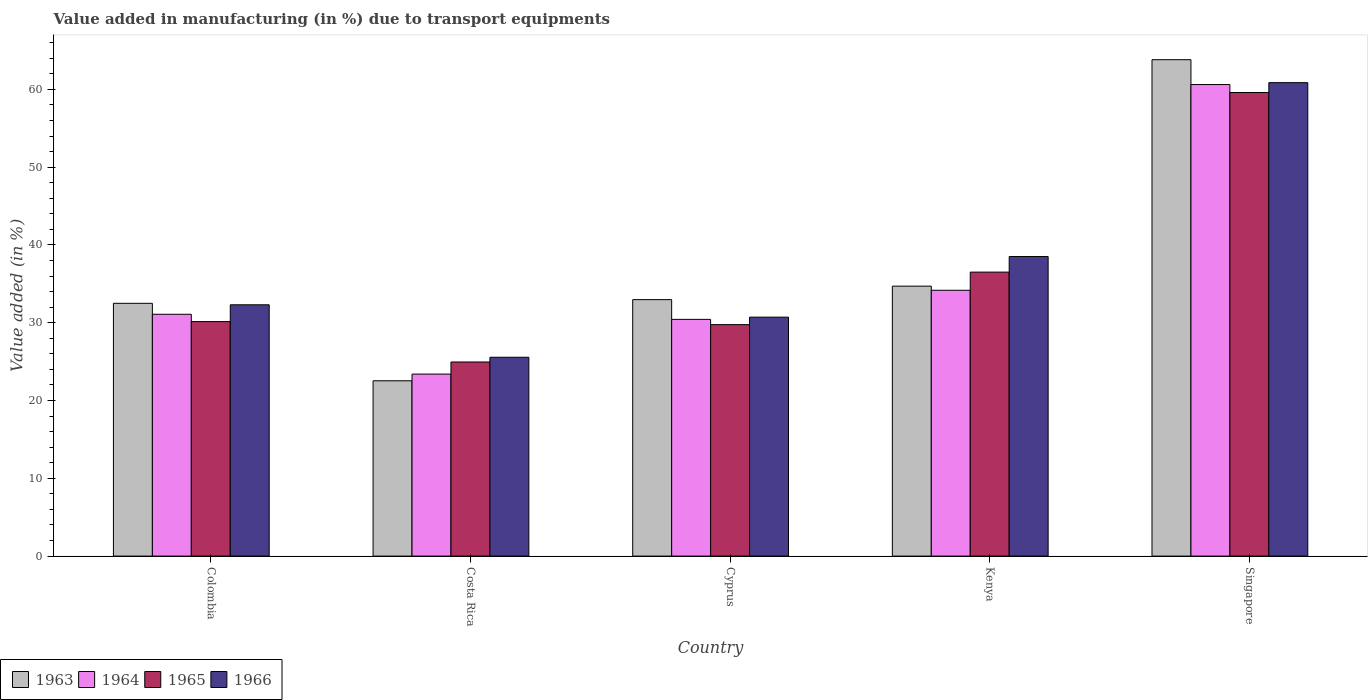How many different coloured bars are there?
Keep it short and to the point. 4. How many groups of bars are there?
Offer a terse response. 5. Are the number of bars on each tick of the X-axis equal?
Offer a very short reply. Yes. How many bars are there on the 2nd tick from the right?
Make the answer very short. 4. What is the label of the 1st group of bars from the left?
Your response must be concise. Colombia. What is the percentage of value added in manufacturing due to transport equipments in 1965 in Cyprus?
Keep it short and to the point. 29.75. Across all countries, what is the maximum percentage of value added in manufacturing due to transport equipments in 1965?
Offer a terse response. 59.59. Across all countries, what is the minimum percentage of value added in manufacturing due to transport equipments in 1963?
Your answer should be compact. 22.53. In which country was the percentage of value added in manufacturing due to transport equipments in 1964 maximum?
Provide a succinct answer. Singapore. What is the total percentage of value added in manufacturing due to transport equipments in 1963 in the graph?
Ensure brevity in your answer.  186.5. What is the difference between the percentage of value added in manufacturing due to transport equipments in 1966 in Costa Rica and that in Singapore?
Your answer should be compact. -35.3. What is the difference between the percentage of value added in manufacturing due to transport equipments in 1964 in Costa Rica and the percentage of value added in manufacturing due to transport equipments in 1963 in Kenya?
Keep it short and to the point. -11.3. What is the average percentage of value added in manufacturing due to transport equipments in 1966 per country?
Provide a short and direct response. 37.59. What is the difference between the percentage of value added in manufacturing due to transport equipments of/in 1963 and percentage of value added in manufacturing due to transport equipments of/in 1964 in Cyprus?
Offer a terse response. 2.54. What is the ratio of the percentage of value added in manufacturing due to transport equipments in 1965 in Costa Rica to that in Singapore?
Your answer should be compact. 0.42. Is the difference between the percentage of value added in manufacturing due to transport equipments in 1963 in Costa Rica and Singapore greater than the difference between the percentage of value added in manufacturing due to transport equipments in 1964 in Costa Rica and Singapore?
Your answer should be compact. No. What is the difference between the highest and the second highest percentage of value added in manufacturing due to transport equipments in 1963?
Your answer should be compact. -1.73. What is the difference between the highest and the lowest percentage of value added in manufacturing due to transport equipments in 1966?
Your answer should be very brief. 35.3. In how many countries, is the percentage of value added in manufacturing due to transport equipments in 1966 greater than the average percentage of value added in manufacturing due to transport equipments in 1966 taken over all countries?
Provide a succinct answer. 2. Is the sum of the percentage of value added in manufacturing due to transport equipments in 1966 in Costa Rica and Kenya greater than the maximum percentage of value added in manufacturing due to transport equipments in 1965 across all countries?
Provide a succinct answer. Yes. What does the 3rd bar from the left in Singapore represents?
Provide a succinct answer. 1965. What does the 3rd bar from the right in Costa Rica represents?
Ensure brevity in your answer.  1964. Are all the bars in the graph horizontal?
Provide a short and direct response. No. Are the values on the major ticks of Y-axis written in scientific E-notation?
Keep it short and to the point. No. Does the graph contain grids?
Provide a succinct answer. No. What is the title of the graph?
Your answer should be compact. Value added in manufacturing (in %) due to transport equipments. Does "1977" appear as one of the legend labels in the graph?
Your response must be concise. No. What is the label or title of the X-axis?
Keep it short and to the point. Country. What is the label or title of the Y-axis?
Give a very brief answer. Value added (in %). What is the Value added (in %) in 1963 in Colombia?
Make the answer very short. 32.49. What is the Value added (in %) in 1964 in Colombia?
Keep it short and to the point. 31.09. What is the Value added (in %) of 1965 in Colombia?
Make the answer very short. 30.15. What is the Value added (in %) of 1966 in Colombia?
Make the answer very short. 32.3. What is the Value added (in %) of 1963 in Costa Rica?
Make the answer very short. 22.53. What is the Value added (in %) of 1964 in Costa Rica?
Ensure brevity in your answer.  23.4. What is the Value added (in %) in 1965 in Costa Rica?
Your answer should be very brief. 24.95. What is the Value added (in %) in 1966 in Costa Rica?
Provide a short and direct response. 25.56. What is the Value added (in %) in 1963 in Cyprus?
Make the answer very short. 32.97. What is the Value added (in %) in 1964 in Cyprus?
Offer a very short reply. 30.43. What is the Value added (in %) of 1965 in Cyprus?
Keep it short and to the point. 29.75. What is the Value added (in %) in 1966 in Cyprus?
Your answer should be very brief. 30.72. What is the Value added (in %) of 1963 in Kenya?
Keep it short and to the point. 34.7. What is the Value added (in %) of 1964 in Kenya?
Offer a terse response. 34.17. What is the Value added (in %) of 1965 in Kenya?
Ensure brevity in your answer.  36.5. What is the Value added (in %) in 1966 in Kenya?
Make the answer very short. 38.51. What is the Value added (in %) in 1963 in Singapore?
Your response must be concise. 63.81. What is the Value added (in %) in 1964 in Singapore?
Offer a terse response. 60.62. What is the Value added (in %) in 1965 in Singapore?
Ensure brevity in your answer.  59.59. What is the Value added (in %) of 1966 in Singapore?
Offer a terse response. 60.86. Across all countries, what is the maximum Value added (in %) in 1963?
Ensure brevity in your answer.  63.81. Across all countries, what is the maximum Value added (in %) of 1964?
Make the answer very short. 60.62. Across all countries, what is the maximum Value added (in %) of 1965?
Give a very brief answer. 59.59. Across all countries, what is the maximum Value added (in %) of 1966?
Your answer should be compact. 60.86. Across all countries, what is the minimum Value added (in %) of 1963?
Offer a very short reply. 22.53. Across all countries, what is the minimum Value added (in %) of 1964?
Give a very brief answer. 23.4. Across all countries, what is the minimum Value added (in %) of 1965?
Offer a very short reply. 24.95. Across all countries, what is the minimum Value added (in %) in 1966?
Provide a succinct answer. 25.56. What is the total Value added (in %) of 1963 in the graph?
Your answer should be very brief. 186.5. What is the total Value added (in %) in 1964 in the graph?
Offer a very short reply. 179.7. What is the total Value added (in %) in 1965 in the graph?
Keep it short and to the point. 180.94. What is the total Value added (in %) of 1966 in the graph?
Give a very brief answer. 187.95. What is the difference between the Value added (in %) in 1963 in Colombia and that in Costa Rica?
Give a very brief answer. 9.96. What is the difference between the Value added (in %) in 1964 in Colombia and that in Costa Rica?
Ensure brevity in your answer.  7.69. What is the difference between the Value added (in %) of 1965 in Colombia and that in Costa Rica?
Offer a terse response. 5.2. What is the difference between the Value added (in %) in 1966 in Colombia and that in Costa Rica?
Keep it short and to the point. 6.74. What is the difference between the Value added (in %) of 1963 in Colombia and that in Cyprus?
Ensure brevity in your answer.  -0.47. What is the difference between the Value added (in %) of 1964 in Colombia and that in Cyprus?
Provide a succinct answer. 0.66. What is the difference between the Value added (in %) of 1965 in Colombia and that in Cyprus?
Keep it short and to the point. 0.39. What is the difference between the Value added (in %) of 1966 in Colombia and that in Cyprus?
Provide a short and direct response. 1.59. What is the difference between the Value added (in %) in 1963 in Colombia and that in Kenya?
Your answer should be compact. -2.21. What is the difference between the Value added (in %) of 1964 in Colombia and that in Kenya?
Make the answer very short. -3.08. What is the difference between the Value added (in %) in 1965 in Colombia and that in Kenya?
Give a very brief answer. -6.36. What is the difference between the Value added (in %) of 1966 in Colombia and that in Kenya?
Give a very brief answer. -6.2. What is the difference between the Value added (in %) of 1963 in Colombia and that in Singapore?
Your answer should be compact. -31.32. What is the difference between the Value added (in %) of 1964 in Colombia and that in Singapore?
Give a very brief answer. -29.53. What is the difference between the Value added (in %) in 1965 in Colombia and that in Singapore?
Your answer should be compact. -29.45. What is the difference between the Value added (in %) in 1966 in Colombia and that in Singapore?
Ensure brevity in your answer.  -28.56. What is the difference between the Value added (in %) of 1963 in Costa Rica and that in Cyprus?
Offer a very short reply. -10.43. What is the difference between the Value added (in %) in 1964 in Costa Rica and that in Cyprus?
Give a very brief answer. -7.03. What is the difference between the Value added (in %) of 1965 in Costa Rica and that in Cyprus?
Your response must be concise. -4.8. What is the difference between the Value added (in %) of 1966 in Costa Rica and that in Cyprus?
Ensure brevity in your answer.  -5.16. What is the difference between the Value added (in %) in 1963 in Costa Rica and that in Kenya?
Provide a succinct answer. -12.17. What is the difference between the Value added (in %) in 1964 in Costa Rica and that in Kenya?
Offer a terse response. -10.77. What is the difference between the Value added (in %) of 1965 in Costa Rica and that in Kenya?
Ensure brevity in your answer.  -11.55. What is the difference between the Value added (in %) in 1966 in Costa Rica and that in Kenya?
Keep it short and to the point. -12.95. What is the difference between the Value added (in %) of 1963 in Costa Rica and that in Singapore?
Ensure brevity in your answer.  -41.28. What is the difference between the Value added (in %) in 1964 in Costa Rica and that in Singapore?
Offer a terse response. -37.22. What is the difference between the Value added (in %) of 1965 in Costa Rica and that in Singapore?
Ensure brevity in your answer.  -34.64. What is the difference between the Value added (in %) of 1966 in Costa Rica and that in Singapore?
Provide a short and direct response. -35.3. What is the difference between the Value added (in %) of 1963 in Cyprus and that in Kenya?
Ensure brevity in your answer.  -1.73. What is the difference between the Value added (in %) in 1964 in Cyprus and that in Kenya?
Offer a terse response. -3.74. What is the difference between the Value added (in %) in 1965 in Cyprus and that in Kenya?
Your answer should be very brief. -6.75. What is the difference between the Value added (in %) of 1966 in Cyprus and that in Kenya?
Make the answer very short. -7.79. What is the difference between the Value added (in %) in 1963 in Cyprus and that in Singapore?
Keep it short and to the point. -30.84. What is the difference between the Value added (in %) of 1964 in Cyprus and that in Singapore?
Your answer should be compact. -30.19. What is the difference between the Value added (in %) in 1965 in Cyprus and that in Singapore?
Your answer should be very brief. -29.84. What is the difference between the Value added (in %) of 1966 in Cyprus and that in Singapore?
Provide a succinct answer. -30.14. What is the difference between the Value added (in %) of 1963 in Kenya and that in Singapore?
Your answer should be very brief. -29.11. What is the difference between the Value added (in %) in 1964 in Kenya and that in Singapore?
Give a very brief answer. -26.45. What is the difference between the Value added (in %) of 1965 in Kenya and that in Singapore?
Offer a very short reply. -23.09. What is the difference between the Value added (in %) in 1966 in Kenya and that in Singapore?
Make the answer very short. -22.35. What is the difference between the Value added (in %) of 1963 in Colombia and the Value added (in %) of 1964 in Costa Rica?
Your answer should be compact. 9.1. What is the difference between the Value added (in %) of 1963 in Colombia and the Value added (in %) of 1965 in Costa Rica?
Offer a terse response. 7.54. What is the difference between the Value added (in %) of 1963 in Colombia and the Value added (in %) of 1966 in Costa Rica?
Provide a succinct answer. 6.93. What is the difference between the Value added (in %) in 1964 in Colombia and the Value added (in %) in 1965 in Costa Rica?
Give a very brief answer. 6.14. What is the difference between the Value added (in %) of 1964 in Colombia and the Value added (in %) of 1966 in Costa Rica?
Offer a very short reply. 5.53. What is the difference between the Value added (in %) of 1965 in Colombia and the Value added (in %) of 1966 in Costa Rica?
Keep it short and to the point. 4.59. What is the difference between the Value added (in %) of 1963 in Colombia and the Value added (in %) of 1964 in Cyprus?
Offer a very short reply. 2.06. What is the difference between the Value added (in %) in 1963 in Colombia and the Value added (in %) in 1965 in Cyprus?
Ensure brevity in your answer.  2.74. What is the difference between the Value added (in %) in 1963 in Colombia and the Value added (in %) in 1966 in Cyprus?
Make the answer very short. 1.78. What is the difference between the Value added (in %) in 1964 in Colombia and the Value added (in %) in 1965 in Cyprus?
Keep it short and to the point. 1.33. What is the difference between the Value added (in %) of 1964 in Colombia and the Value added (in %) of 1966 in Cyprus?
Give a very brief answer. 0.37. What is the difference between the Value added (in %) of 1965 in Colombia and the Value added (in %) of 1966 in Cyprus?
Your answer should be very brief. -0.57. What is the difference between the Value added (in %) of 1963 in Colombia and the Value added (in %) of 1964 in Kenya?
Your response must be concise. -1.68. What is the difference between the Value added (in %) in 1963 in Colombia and the Value added (in %) in 1965 in Kenya?
Your answer should be very brief. -4.01. What is the difference between the Value added (in %) in 1963 in Colombia and the Value added (in %) in 1966 in Kenya?
Provide a short and direct response. -6.01. What is the difference between the Value added (in %) in 1964 in Colombia and the Value added (in %) in 1965 in Kenya?
Provide a short and direct response. -5.42. What is the difference between the Value added (in %) of 1964 in Colombia and the Value added (in %) of 1966 in Kenya?
Ensure brevity in your answer.  -7.42. What is the difference between the Value added (in %) of 1965 in Colombia and the Value added (in %) of 1966 in Kenya?
Give a very brief answer. -8.36. What is the difference between the Value added (in %) in 1963 in Colombia and the Value added (in %) in 1964 in Singapore?
Your answer should be very brief. -28.12. What is the difference between the Value added (in %) in 1963 in Colombia and the Value added (in %) in 1965 in Singapore?
Offer a very short reply. -27.1. What is the difference between the Value added (in %) in 1963 in Colombia and the Value added (in %) in 1966 in Singapore?
Your response must be concise. -28.37. What is the difference between the Value added (in %) of 1964 in Colombia and the Value added (in %) of 1965 in Singapore?
Provide a short and direct response. -28.51. What is the difference between the Value added (in %) in 1964 in Colombia and the Value added (in %) in 1966 in Singapore?
Ensure brevity in your answer.  -29.77. What is the difference between the Value added (in %) in 1965 in Colombia and the Value added (in %) in 1966 in Singapore?
Your response must be concise. -30.71. What is the difference between the Value added (in %) in 1963 in Costa Rica and the Value added (in %) in 1964 in Cyprus?
Keep it short and to the point. -7.9. What is the difference between the Value added (in %) in 1963 in Costa Rica and the Value added (in %) in 1965 in Cyprus?
Offer a terse response. -7.22. What is the difference between the Value added (in %) in 1963 in Costa Rica and the Value added (in %) in 1966 in Cyprus?
Provide a short and direct response. -8.18. What is the difference between the Value added (in %) of 1964 in Costa Rica and the Value added (in %) of 1965 in Cyprus?
Offer a terse response. -6.36. What is the difference between the Value added (in %) in 1964 in Costa Rica and the Value added (in %) in 1966 in Cyprus?
Provide a short and direct response. -7.32. What is the difference between the Value added (in %) in 1965 in Costa Rica and the Value added (in %) in 1966 in Cyprus?
Give a very brief answer. -5.77. What is the difference between the Value added (in %) of 1963 in Costa Rica and the Value added (in %) of 1964 in Kenya?
Your response must be concise. -11.64. What is the difference between the Value added (in %) of 1963 in Costa Rica and the Value added (in %) of 1965 in Kenya?
Ensure brevity in your answer.  -13.97. What is the difference between the Value added (in %) of 1963 in Costa Rica and the Value added (in %) of 1966 in Kenya?
Provide a succinct answer. -15.97. What is the difference between the Value added (in %) of 1964 in Costa Rica and the Value added (in %) of 1965 in Kenya?
Give a very brief answer. -13.11. What is the difference between the Value added (in %) in 1964 in Costa Rica and the Value added (in %) in 1966 in Kenya?
Keep it short and to the point. -15.11. What is the difference between the Value added (in %) in 1965 in Costa Rica and the Value added (in %) in 1966 in Kenya?
Ensure brevity in your answer.  -13.56. What is the difference between the Value added (in %) in 1963 in Costa Rica and the Value added (in %) in 1964 in Singapore?
Your response must be concise. -38.08. What is the difference between the Value added (in %) in 1963 in Costa Rica and the Value added (in %) in 1965 in Singapore?
Offer a very short reply. -37.06. What is the difference between the Value added (in %) of 1963 in Costa Rica and the Value added (in %) of 1966 in Singapore?
Give a very brief answer. -38.33. What is the difference between the Value added (in %) of 1964 in Costa Rica and the Value added (in %) of 1965 in Singapore?
Provide a succinct answer. -36.19. What is the difference between the Value added (in %) of 1964 in Costa Rica and the Value added (in %) of 1966 in Singapore?
Your answer should be compact. -37.46. What is the difference between the Value added (in %) in 1965 in Costa Rica and the Value added (in %) in 1966 in Singapore?
Your answer should be compact. -35.91. What is the difference between the Value added (in %) of 1963 in Cyprus and the Value added (in %) of 1964 in Kenya?
Offer a terse response. -1.2. What is the difference between the Value added (in %) of 1963 in Cyprus and the Value added (in %) of 1965 in Kenya?
Your answer should be very brief. -3.54. What is the difference between the Value added (in %) in 1963 in Cyprus and the Value added (in %) in 1966 in Kenya?
Your answer should be very brief. -5.54. What is the difference between the Value added (in %) of 1964 in Cyprus and the Value added (in %) of 1965 in Kenya?
Provide a short and direct response. -6.07. What is the difference between the Value added (in %) of 1964 in Cyprus and the Value added (in %) of 1966 in Kenya?
Ensure brevity in your answer.  -8.08. What is the difference between the Value added (in %) of 1965 in Cyprus and the Value added (in %) of 1966 in Kenya?
Make the answer very short. -8.75. What is the difference between the Value added (in %) of 1963 in Cyprus and the Value added (in %) of 1964 in Singapore?
Offer a very short reply. -27.65. What is the difference between the Value added (in %) of 1963 in Cyprus and the Value added (in %) of 1965 in Singapore?
Your answer should be compact. -26.62. What is the difference between the Value added (in %) in 1963 in Cyprus and the Value added (in %) in 1966 in Singapore?
Offer a very short reply. -27.89. What is the difference between the Value added (in %) of 1964 in Cyprus and the Value added (in %) of 1965 in Singapore?
Ensure brevity in your answer.  -29.16. What is the difference between the Value added (in %) of 1964 in Cyprus and the Value added (in %) of 1966 in Singapore?
Ensure brevity in your answer.  -30.43. What is the difference between the Value added (in %) in 1965 in Cyprus and the Value added (in %) in 1966 in Singapore?
Your response must be concise. -31.11. What is the difference between the Value added (in %) of 1963 in Kenya and the Value added (in %) of 1964 in Singapore?
Offer a terse response. -25.92. What is the difference between the Value added (in %) of 1963 in Kenya and the Value added (in %) of 1965 in Singapore?
Give a very brief answer. -24.89. What is the difference between the Value added (in %) of 1963 in Kenya and the Value added (in %) of 1966 in Singapore?
Ensure brevity in your answer.  -26.16. What is the difference between the Value added (in %) of 1964 in Kenya and the Value added (in %) of 1965 in Singapore?
Offer a terse response. -25.42. What is the difference between the Value added (in %) of 1964 in Kenya and the Value added (in %) of 1966 in Singapore?
Make the answer very short. -26.69. What is the difference between the Value added (in %) of 1965 in Kenya and the Value added (in %) of 1966 in Singapore?
Give a very brief answer. -24.36. What is the average Value added (in %) in 1963 per country?
Provide a succinct answer. 37.3. What is the average Value added (in %) in 1964 per country?
Make the answer very short. 35.94. What is the average Value added (in %) in 1965 per country?
Offer a terse response. 36.19. What is the average Value added (in %) of 1966 per country?
Your answer should be very brief. 37.59. What is the difference between the Value added (in %) of 1963 and Value added (in %) of 1964 in Colombia?
Offer a very short reply. 1.41. What is the difference between the Value added (in %) of 1963 and Value added (in %) of 1965 in Colombia?
Offer a terse response. 2.35. What is the difference between the Value added (in %) in 1963 and Value added (in %) in 1966 in Colombia?
Provide a short and direct response. 0.19. What is the difference between the Value added (in %) in 1964 and Value added (in %) in 1965 in Colombia?
Make the answer very short. 0.94. What is the difference between the Value added (in %) in 1964 and Value added (in %) in 1966 in Colombia?
Your answer should be very brief. -1.22. What is the difference between the Value added (in %) in 1965 and Value added (in %) in 1966 in Colombia?
Provide a succinct answer. -2.16. What is the difference between the Value added (in %) of 1963 and Value added (in %) of 1964 in Costa Rica?
Your answer should be compact. -0.86. What is the difference between the Value added (in %) in 1963 and Value added (in %) in 1965 in Costa Rica?
Make the answer very short. -2.42. What is the difference between the Value added (in %) in 1963 and Value added (in %) in 1966 in Costa Rica?
Offer a very short reply. -3.03. What is the difference between the Value added (in %) in 1964 and Value added (in %) in 1965 in Costa Rica?
Ensure brevity in your answer.  -1.55. What is the difference between the Value added (in %) in 1964 and Value added (in %) in 1966 in Costa Rica?
Provide a short and direct response. -2.16. What is the difference between the Value added (in %) in 1965 and Value added (in %) in 1966 in Costa Rica?
Make the answer very short. -0.61. What is the difference between the Value added (in %) of 1963 and Value added (in %) of 1964 in Cyprus?
Give a very brief answer. 2.54. What is the difference between the Value added (in %) of 1963 and Value added (in %) of 1965 in Cyprus?
Your answer should be compact. 3.21. What is the difference between the Value added (in %) of 1963 and Value added (in %) of 1966 in Cyprus?
Your response must be concise. 2.25. What is the difference between the Value added (in %) of 1964 and Value added (in %) of 1965 in Cyprus?
Your response must be concise. 0.68. What is the difference between the Value added (in %) in 1964 and Value added (in %) in 1966 in Cyprus?
Provide a succinct answer. -0.29. What is the difference between the Value added (in %) in 1965 and Value added (in %) in 1966 in Cyprus?
Your answer should be very brief. -0.96. What is the difference between the Value added (in %) of 1963 and Value added (in %) of 1964 in Kenya?
Offer a terse response. 0.53. What is the difference between the Value added (in %) in 1963 and Value added (in %) in 1965 in Kenya?
Make the answer very short. -1.8. What is the difference between the Value added (in %) of 1963 and Value added (in %) of 1966 in Kenya?
Ensure brevity in your answer.  -3.81. What is the difference between the Value added (in %) in 1964 and Value added (in %) in 1965 in Kenya?
Your answer should be compact. -2.33. What is the difference between the Value added (in %) in 1964 and Value added (in %) in 1966 in Kenya?
Your answer should be very brief. -4.34. What is the difference between the Value added (in %) in 1965 and Value added (in %) in 1966 in Kenya?
Your response must be concise. -2. What is the difference between the Value added (in %) in 1963 and Value added (in %) in 1964 in Singapore?
Your response must be concise. 3.19. What is the difference between the Value added (in %) in 1963 and Value added (in %) in 1965 in Singapore?
Keep it short and to the point. 4.22. What is the difference between the Value added (in %) of 1963 and Value added (in %) of 1966 in Singapore?
Offer a very short reply. 2.95. What is the difference between the Value added (in %) in 1964 and Value added (in %) in 1965 in Singapore?
Give a very brief answer. 1.03. What is the difference between the Value added (in %) in 1964 and Value added (in %) in 1966 in Singapore?
Offer a terse response. -0.24. What is the difference between the Value added (in %) in 1965 and Value added (in %) in 1966 in Singapore?
Offer a terse response. -1.27. What is the ratio of the Value added (in %) of 1963 in Colombia to that in Costa Rica?
Make the answer very short. 1.44. What is the ratio of the Value added (in %) of 1964 in Colombia to that in Costa Rica?
Offer a very short reply. 1.33. What is the ratio of the Value added (in %) in 1965 in Colombia to that in Costa Rica?
Your answer should be very brief. 1.21. What is the ratio of the Value added (in %) in 1966 in Colombia to that in Costa Rica?
Offer a terse response. 1.26. What is the ratio of the Value added (in %) of 1963 in Colombia to that in Cyprus?
Make the answer very short. 0.99. What is the ratio of the Value added (in %) in 1964 in Colombia to that in Cyprus?
Your response must be concise. 1.02. What is the ratio of the Value added (in %) in 1965 in Colombia to that in Cyprus?
Provide a short and direct response. 1.01. What is the ratio of the Value added (in %) in 1966 in Colombia to that in Cyprus?
Provide a succinct answer. 1.05. What is the ratio of the Value added (in %) of 1963 in Colombia to that in Kenya?
Your answer should be compact. 0.94. What is the ratio of the Value added (in %) of 1964 in Colombia to that in Kenya?
Keep it short and to the point. 0.91. What is the ratio of the Value added (in %) in 1965 in Colombia to that in Kenya?
Offer a terse response. 0.83. What is the ratio of the Value added (in %) in 1966 in Colombia to that in Kenya?
Your response must be concise. 0.84. What is the ratio of the Value added (in %) of 1963 in Colombia to that in Singapore?
Give a very brief answer. 0.51. What is the ratio of the Value added (in %) in 1964 in Colombia to that in Singapore?
Your answer should be very brief. 0.51. What is the ratio of the Value added (in %) of 1965 in Colombia to that in Singapore?
Your answer should be compact. 0.51. What is the ratio of the Value added (in %) in 1966 in Colombia to that in Singapore?
Offer a very short reply. 0.53. What is the ratio of the Value added (in %) in 1963 in Costa Rica to that in Cyprus?
Ensure brevity in your answer.  0.68. What is the ratio of the Value added (in %) of 1964 in Costa Rica to that in Cyprus?
Your answer should be compact. 0.77. What is the ratio of the Value added (in %) in 1965 in Costa Rica to that in Cyprus?
Your answer should be very brief. 0.84. What is the ratio of the Value added (in %) of 1966 in Costa Rica to that in Cyprus?
Your answer should be compact. 0.83. What is the ratio of the Value added (in %) in 1963 in Costa Rica to that in Kenya?
Your answer should be very brief. 0.65. What is the ratio of the Value added (in %) in 1964 in Costa Rica to that in Kenya?
Ensure brevity in your answer.  0.68. What is the ratio of the Value added (in %) of 1965 in Costa Rica to that in Kenya?
Offer a very short reply. 0.68. What is the ratio of the Value added (in %) of 1966 in Costa Rica to that in Kenya?
Offer a very short reply. 0.66. What is the ratio of the Value added (in %) of 1963 in Costa Rica to that in Singapore?
Make the answer very short. 0.35. What is the ratio of the Value added (in %) in 1964 in Costa Rica to that in Singapore?
Ensure brevity in your answer.  0.39. What is the ratio of the Value added (in %) in 1965 in Costa Rica to that in Singapore?
Your response must be concise. 0.42. What is the ratio of the Value added (in %) of 1966 in Costa Rica to that in Singapore?
Provide a short and direct response. 0.42. What is the ratio of the Value added (in %) of 1963 in Cyprus to that in Kenya?
Your response must be concise. 0.95. What is the ratio of the Value added (in %) of 1964 in Cyprus to that in Kenya?
Offer a terse response. 0.89. What is the ratio of the Value added (in %) of 1965 in Cyprus to that in Kenya?
Offer a terse response. 0.82. What is the ratio of the Value added (in %) in 1966 in Cyprus to that in Kenya?
Your response must be concise. 0.8. What is the ratio of the Value added (in %) of 1963 in Cyprus to that in Singapore?
Offer a terse response. 0.52. What is the ratio of the Value added (in %) of 1964 in Cyprus to that in Singapore?
Keep it short and to the point. 0.5. What is the ratio of the Value added (in %) of 1965 in Cyprus to that in Singapore?
Provide a short and direct response. 0.5. What is the ratio of the Value added (in %) of 1966 in Cyprus to that in Singapore?
Ensure brevity in your answer.  0.5. What is the ratio of the Value added (in %) of 1963 in Kenya to that in Singapore?
Offer a very short reply. 0.54. What is the ratio of the Value added (in %) in 1964 in Kenya to that in Singapore?
Your answer should be compact. 0.56. What is the ratio of the Value added (in %) in 1965 in Kenya to that in Singapore?
Ensure brevity in your answer.  0.61. What is the ratio of the Value added (in %) of 1966 in Kenya to that in Singapore?
Your response must be concise. 0.63. What is the difference between the highest and the second highest Value added (in %) in 1963?
Make the answer very short. 29.11. What is the difference between the highest and the second highest Value added (in %) of 1964?
Your answer should be very brief. 26.45. What is the difference between the highest and the second highest Value added (in %) in 1965?
Give a very brief answer. 23.09. What is the difference between the highest and the second highest Value added (in %) in 1966?
Your answer should be compact. 22.35. What is the difference between the highest and the lowest Value added (in %) of 1963?
Ensure brevity in your answer.  41.28. What is the difference between the highest and the lowest Value added (in %) in 1964?
Your answer should be compact. 37.22. What is the difference between the highest and the lowest Value added (in %) of 1965?
Your answer should be compact. 34.64. What is the difference between the highest and the lowest Value added (in %) in 1966?
Your answer should be compact. 35.3. 